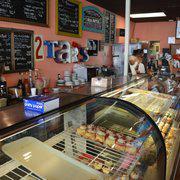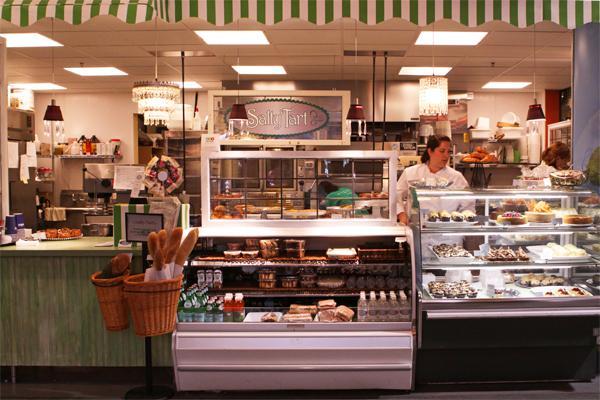The first image is the image on the left, the second image is the image on the right. Evaluate the accuracy of this statement regarding the images: "There is a rounded display case.". Is it true? Answer yes or no. Yes. 